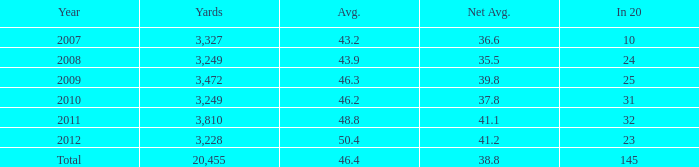What is the equivalent of 32 yards when expressed in 20 units? 1.0. 